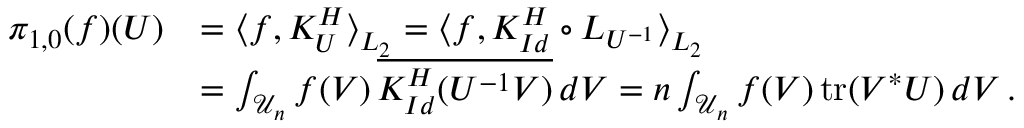<formula> <loc_0><loc_0><loc_500><loc_500>\begin{array} { r l } { \pi _ { 1 , 0 } ( f ) ( U ) } & { = \left \langle f , K _ { U } ^ { H } \right \rangle _ { L _ { 2 } } = \left \langle f , K _ { I d } ^ { H } \circ L _ { U ^ { - 1 } } \right \rangle _ { L _ { 2 } } } \\ & { = \int _ { \mathcal { U } _ { n } } f ( V ) \, \overline { { K _ { I d } ^ { H } ( U ^ { - 1 } V ) } } \, d V = n \int _ { \mathcal { U } _ { n } } f ( V ) \, t r ( V ^ { * } U ) \, d V \, . } \end{array}</formula> 